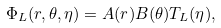Convert formula to latex. <formula><loc_0><loc_0><loc_500><loc_500>\Phi _ { L } ( r , \theta , \eta ) = A ( r ) B ( \theta ) T _ { L } ( \eta ) ,</formula> 